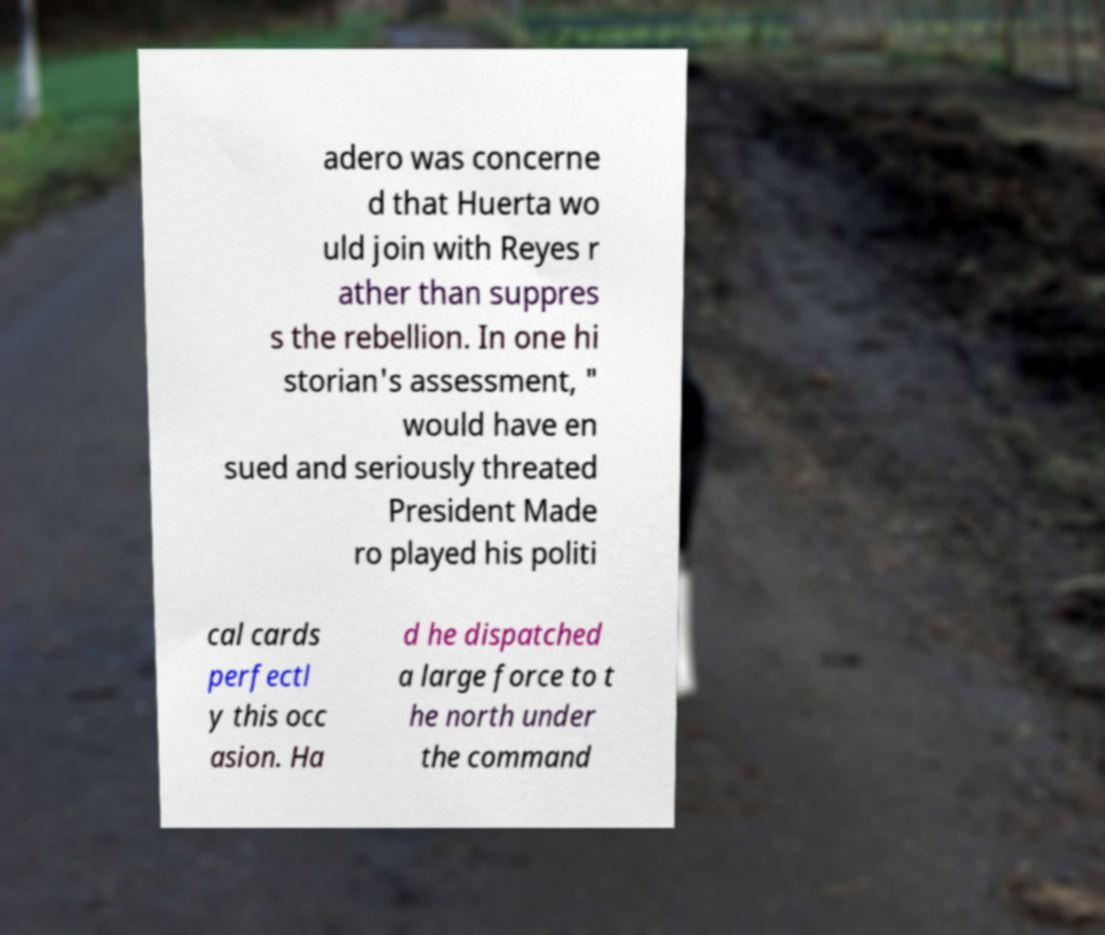Can you accurately transcribe the text from the provided image for me? adero was concerne d that Huerta wo uld join with Reyes r ather than suppres s the rebellion. In one hi storian's assessment, " would have en sued and seriously threated President Made ro played his politi cal cards perfectl y this occ asion. Ha d he dispatched a large force to t he north under the command 